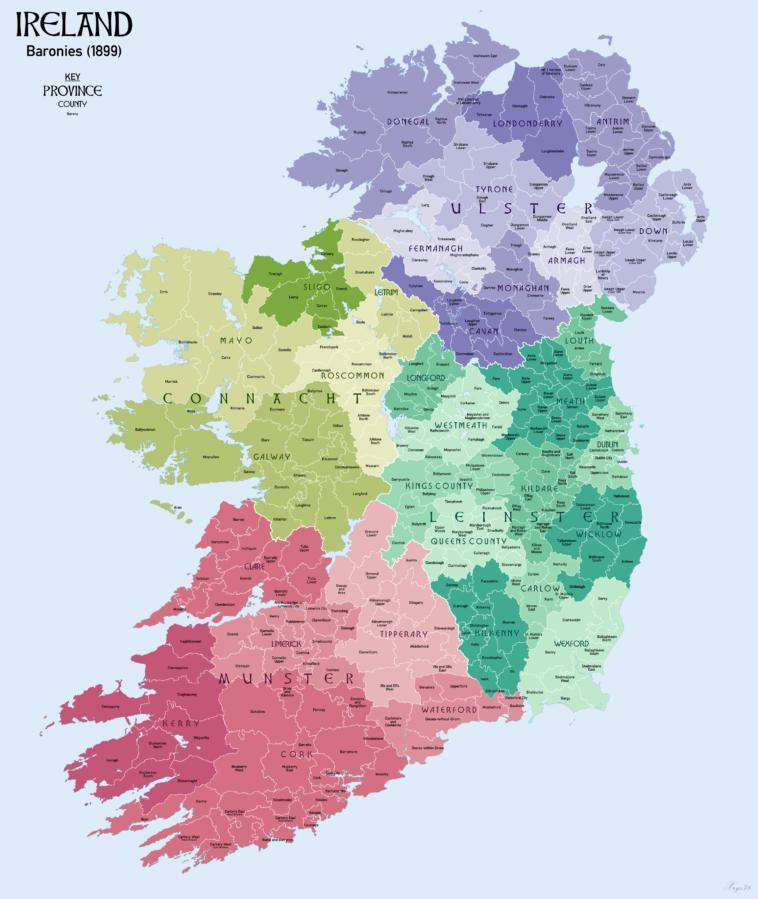Which province lies on the South of Ireland?
Answer the question with a short phrase. Munster How many counties does the Connacht province have? 5 Which two provinces share borders with the province Munster? Connacht, Leinster Which province lies to the north of Ireland? Ulster How many provinces does Ireland have? 4 